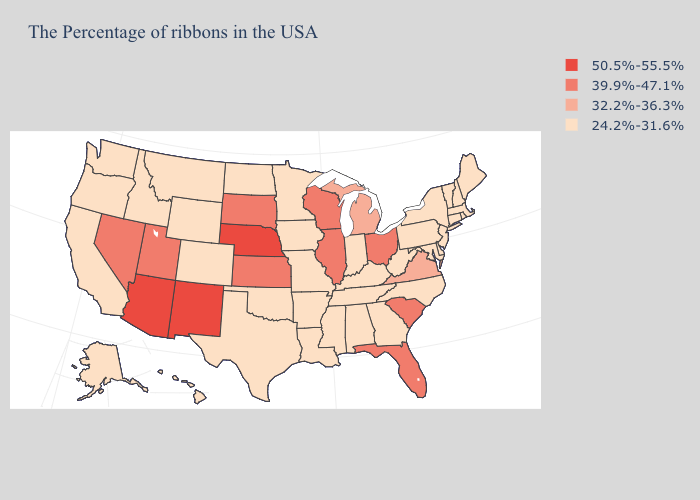Which states have the highest value in the USA?
Answer briefly. Nebraska, New Mexico, Arizona. Name the states that have a value in the range 50.5%-55.5%?
Give a very brief answer. Nebraska, New Mexico, Arizona. Name the states that have a value in the range 50.5%-55.5%?
Short answer required. Nebraska, New Mexico, Arizona. What is the value of Vermont?
Concise answer only. 24.2%-31.6%. Does New Mexico have the lowest value in the USA?
Write a very short answer. No. What is the value of Nebraska?
Concise answer only. 50.5%-55.5%. What is the value of Michigan?
Short answer required. 32.2%-36.3%. Which states hav the highest value in the West?
Answer briefly. New Mexico, Arizona. What is the lowest value in states that border New Hampshire?
Be succinct. 24.2%-31.6%. Which states have the lowest value in the USA?
Keep it brief. Maine, Massachusetts, Rhode Island, New Hampshire, Vermont, Connecticut, New York, New Jersey, Delaware, Maryland, Pennsylvania, North Carolina, West Virginia, Georgia, Kentucky, Indiana, Alabama, Tennessee, Mississippi, Louisiana, Missouri, Arkansas, Minnesota, Iowa, Oklahoma, Texas, North Dakota, Wyoming, Colorado, Montana, Idaho, California, Washington, Oregon, Alaska, Hawaii. What is the value of Wisconsin?
Keep it brief. 39.9%-47.1%. 